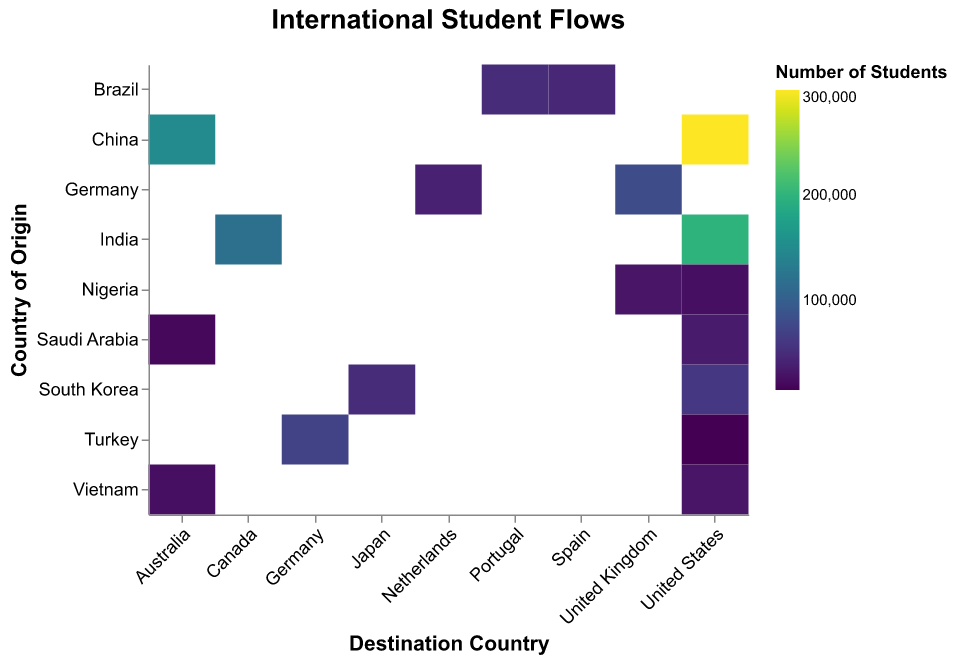What is the title of the figure? The title is located at the top center of the figure and is bold and larger in size than other texts.
Answer: International Student Flows How many students from China go to the United States? By looking at the heatmap cell corresponding to the intersection of China (y-axis) and the United States (x-axis), the number is provided in the tooltip. The tooltip shows "Origin: China", "Destination: United States", "Students: 300000" when hovering over that cell.
Answer: 300,000 Which country has the highest number of students going to the United Kingdom? By inspecting the heatmap cells in the column for the United Kingdom on the x-axis, the cells for Germany and Nigeria are compared. Germany has 80,000 students, which is higher compared to Nigeria's 30,000.
Answer: Germany What is the total number of students from China and India studying in the United States? The number of students from China to the US is 300,000 and from India to the US is 200,000. Summing these values gives the total: 300,000 + 200,000 = 500,000 students.
Answer: 500,000 Which destination country receives the most students from South Korea? Comparing the cells for the destination countries of South Korea on the y-axis, South Korea sends 60,000 students to the United States and 50,000 to Japan. The United States receives more.
Answer: United States What is the average number of students from Brazil to Portugal and Spain? Brazil sends 50,000 students to Portugal and 45,000 to Spain. The average is calculated as (50,000 + 45,000) / 2 = 47,500 students.
Answer: 47,500 Between Vietnam and Saudi Arabia, which one sends more students to Australia? By examining the cells for Vietnam and Saudi Arabia in the Australia column on the x-axis, Vietnam sends 25,000 and Saudi Arabia sends 20,000. Vietnam sends more students.
Answer: Vietnam What is the difference in the number of students from Turkey studying in Germany compared to the United States? Turkey sends 70,000 students to Germany and 15,000 to the United States. The difference is calculated as 70,000 - 15,000 = 55,000 students.
Answer: 55,000 What is the darkest cell in the entire heatmap and what does it represent? The darkest cell is the one with the highest number of students. By visually inspecting the heatmap, the darkest cell is at the intersection of China and the United States. The tooltip confirms it shows 300,000 students.
Answer: China to the United States with 300,000 students 